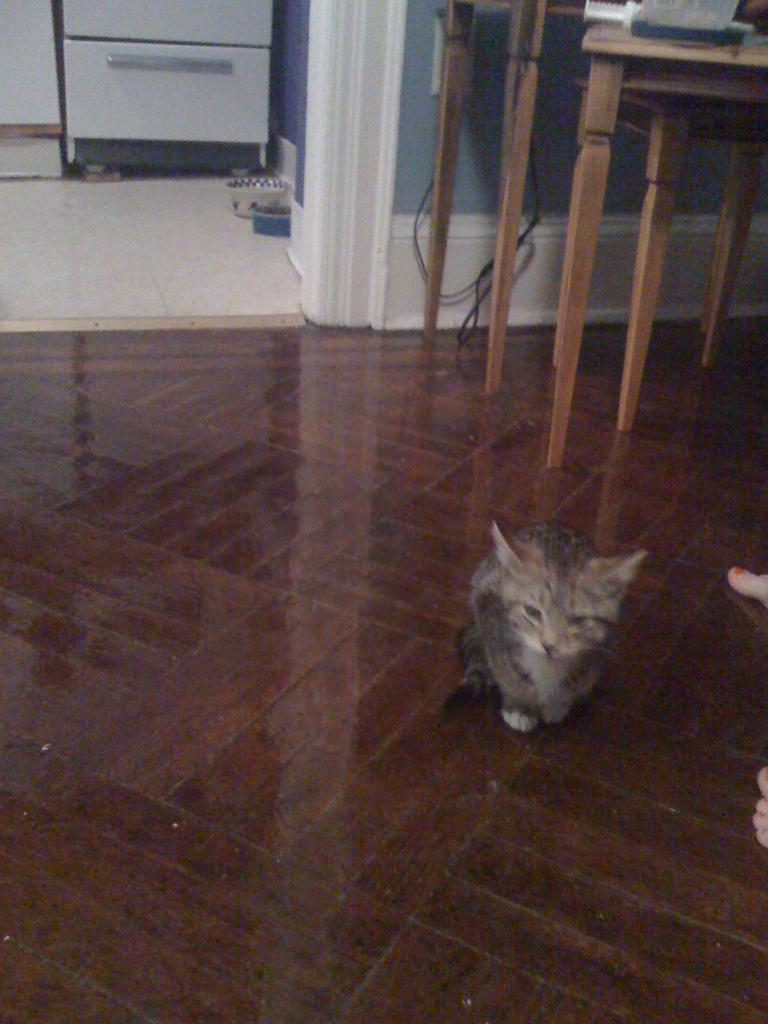What animal can be seen in the image? There is a cat in the image. Where is the cat located in the image? The cat is sitting on the floor. What type of furniture is visible in the background of the image? There is a table and a cupboard in the background of the image. What is the background of the image made of? The background of the image includes a wall. How does the cat participate in the digestion process in the image? The cat does not participate in the digestion process in the image; it is simply sitting on the floor. 